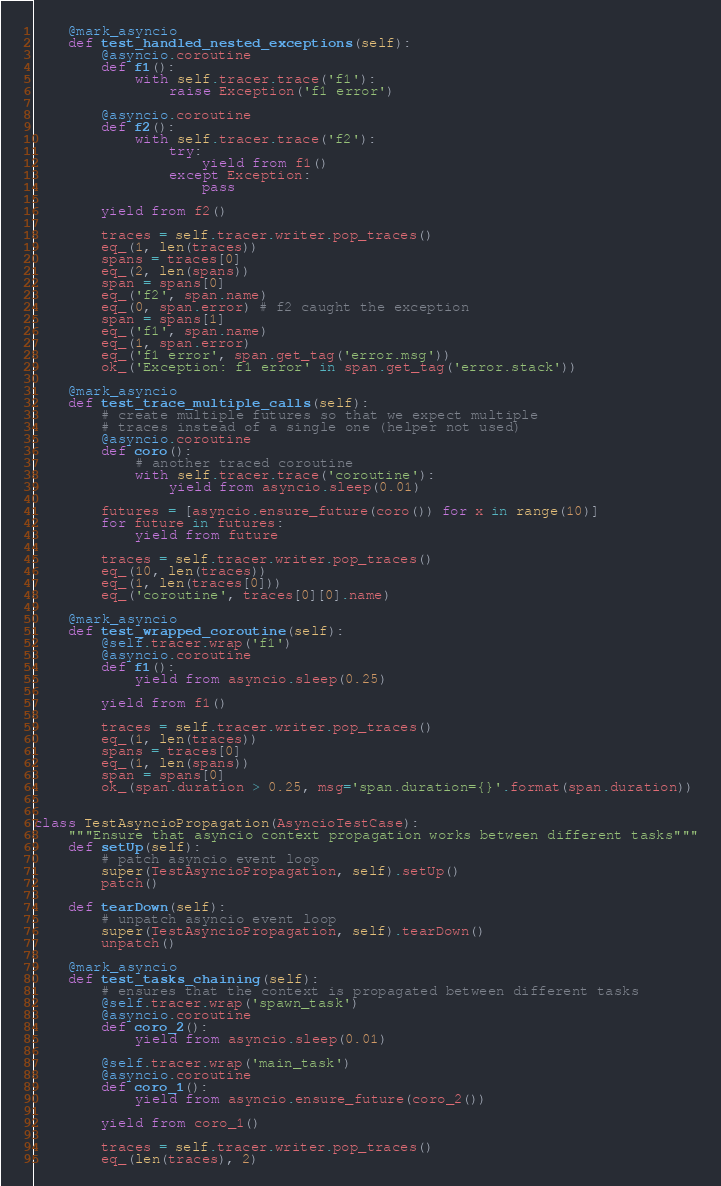Convert code to text. <code><loc_0><loc_0><loc_500><loc_500><_Python_>    @mark_asyncio
    def test_handled_nested_exceptions(self):
        @asyncio.coroutine
        def f1():
            with self.tracer.trace('f1'):
                raise Exception('f1 error')

        @asyncio.coroutine
        def f2():
            with self.tracer.trace('f2'):
                try:
                    yield from f1()
                except Exception:
                    pass

        yield from f2()

        traces = self.tracer.writer.pop_traces()
        eq_(1, len(traces))
        spans = traces[0]
        eq_(2, len(spans))
        span = spans[0]
        eq_('f2', span.name)
        eq_(0, span.error) # f2 caught the exception
        span = spans[1]
        eq_('f1', span.name)
        eq_(1, span.error)
        eq_('f1 error', span.get_tag('error.msg'))
        ok_('Exception: f1 error' in span.get_tag('error.stack'))

    @mark_asyncio
    def test_trace_multiple_calls(self):
        # create multiple futures so that we expect multiple
        # traces instead of a single one (helper not used)
        @asyncio.coroutine
        def coro():
            # another traced coroutine
            with self.tracer.trace('coroutine'):
                yield from asyncio.sleep(0.01)

        futures = [asyncio.ensure_future(coro()) for x in range(10)]
        for future in futures:
            yield from future

        traces = self.tracer.writer.pop_traces()
        eq_(10, len(traces))
        eq_(1, len(traces[0]))
        eq_('coroutine', traces[0][0].name)

    @mark_asyncio
    def test_wrapped_coroutine(self):
        @self.tracer.wrap('f1')
        @asyncio.coroutine
        def f1():
            yield from asyncio.sleep(0.25)

        yield from f1()

        traces = self.tracer.writer.pop_traces()
        eq_(1, len(traces))
        spans = traces[0]
        eq_(1, len(spans))
        span = spans[0]
        ok_(span.duration > 0.25, msg='span.duration={}'.format(span.duration))


class TestAsyncioPropagation(AsyncioTestCase):
    """Ensure that asyncio context propagation works between different tasks"""
    def setUp(self):
        # patch asyncio event loop
        super(TestAsyncioPropagation, self).setUp()
        patch()

    def tearDown(self):
        # unpatch asyncio event loop
        super(TestAsyncioPropagation, self).tearDown()
        unpatch()

    @mark_asyncio
    def test_tasks_chaining(self):
        # ensures that the context is propagated between different tasks
        @self.tracer.wrap('spawn_task')
        @asyncio.coroutine
        def coro_2():
            yield from asyncio.sleep(0.01)

        @self.tracer.wrap('main_task')
        @asyncio.coroutine
        def coro_1():
            yield from asyncio.ensure_future(coro_2())

        yield from coro_1()

        traces = self.tracer.writer.pop_traces()
        eq_(len(traces), 2)</code> 